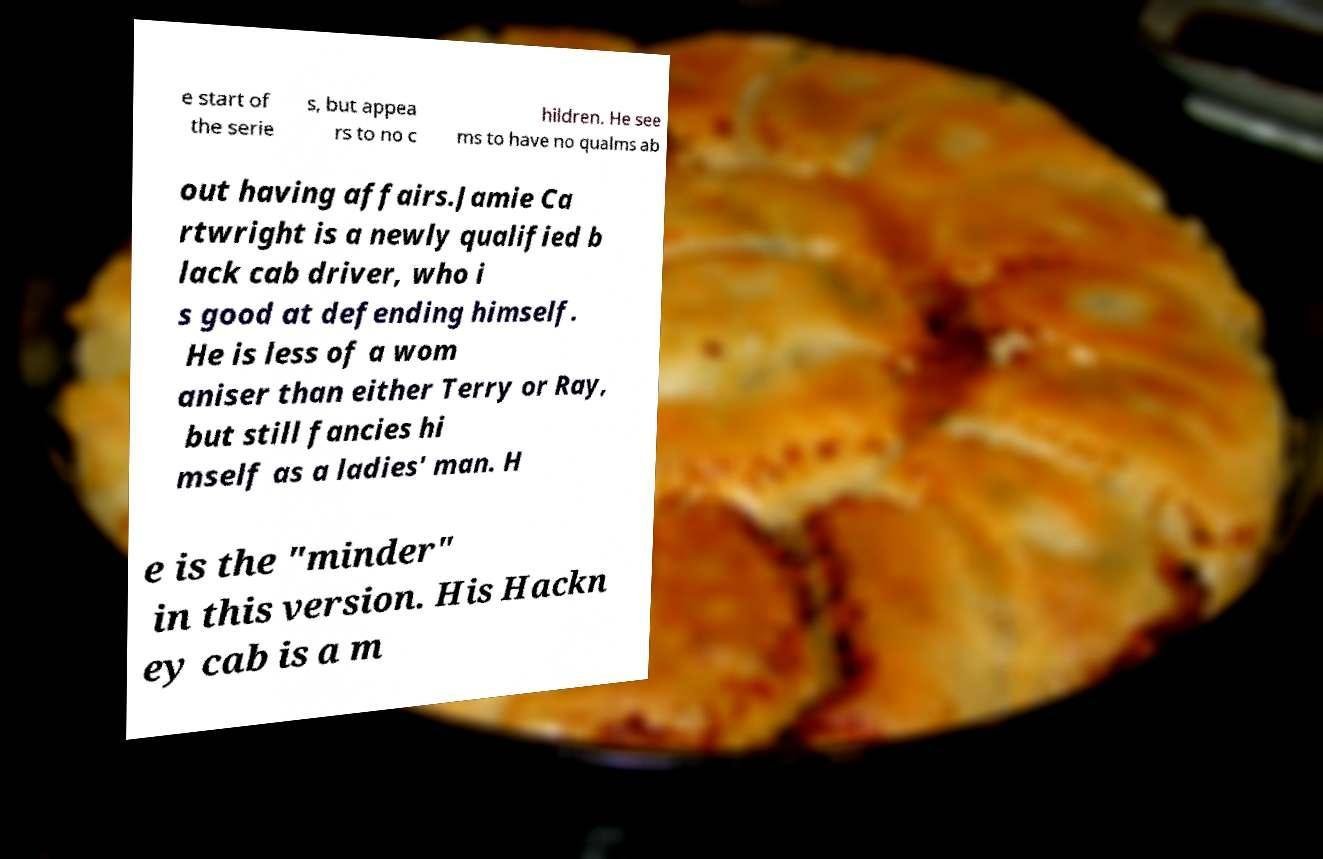Please read and relay the text visible in this image. What does it say? e start of the serie s, but appea rs to no c hildren. He see ms to have no qualms ab out having affairs.Jamie Ca rtwright is a newly qualified b lack cab driver, who i s good at defending himself. He is less of a wom aniser than either Terry or Ray, but still fancies hi mself as a ladies' man. H e is the "minder" in this version. His Hackn ey cab is a m 